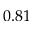Convert formula to latex. <formula><loc_0><loc_0><loc_500><loc_500>0 . 8 1</formula> 